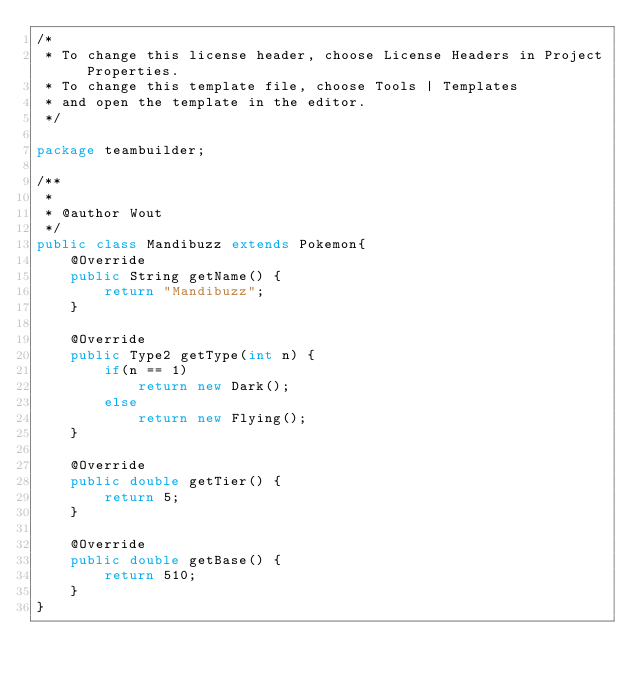Convert code to text. <code><loc_0><loc_0><loc_500><loc_500><_Java_>/*
 * To change this license header, choose License Headers in Project Properties.
 * To change this template file, choose Tools | Templates
 * and open the template in the editor.
 */

package teambuilder;

/**
 *
 * @author Wout
 */
public class Mandibuzz extends Pokemon{
    @Override
    public String getName() {
        return "Mandibuzz";
    }

    @Override
    public Type2 getType(int n) {
        if(n == 1)
            return new Dark();
        else
            return new Flying();
    }
    
    @Override
    public double getTier() {
        return 5;
    }
    
    @Override
    public double getBase() {
        return 510;
    }
}
</code> 